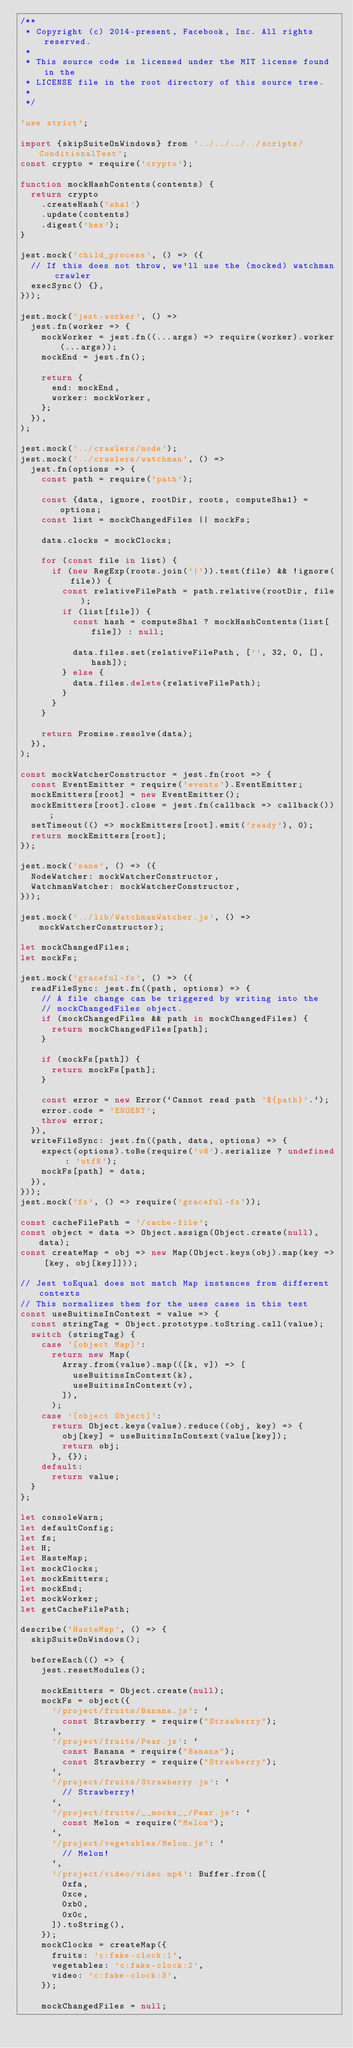Convert code to text. <code><loc_0><loc_0><loc_500><loc_500><_JavaScript_>/**
 * Copyright (c) 2014-present, Facebook, Inc. All rights reserved.
 *
 * This source code is licensed under the MIT license found in the
 * LICENSE file in the root directory of this source tree.
 *
 */

'use strict';

import {skipSuiteOnWindows} from '../../../../scripts/ConditionalTest';
const crypto = require('crypto');

function mockHashContents(contents) {
  return crypto
    .createHash('sha1')
    .update(contents)
    .digest('hex');
}

jest.mock('child_process', () => ({
  // If this does not throw, we'll use the (mocked) watchman crawler
  execSync() {},
}));

jest.mock('jest-worker', () =>
  jest.fn(worker => {
    mockWorker = jest.fn((...args) => require(worker).worker(...args));
    mockEnd = jest.fn();

    return {
      end: mockEnd,
      worker: mockWorker,
    };
  }),
);

jest.mock('../crawlers/node');
jest.mock('../crawlers/watchman', () =>
  jest.fn(options => {
    const path = require('path');

    const {data, ignore, rootDir, roots, computeSha1} = options;
    const list = mockChangedFiles || mockFs;

    data.clocks = mockClocks;

    for (const file in list) {
      if (new RegExp(roots.join('|')).test(file) && !ignore(file)) {
        const relativeFilePath = path.relative(rootDir, file);
        if (list[file]) {
          const hash = computeSha1 ? mockHashContents(list[file]) : null;

          data.files.set(relativeFilePath, ['', 32, 0, [], hash]);
        } else {
          data.files.delete(relativeFilePath);
        }
      }
    }

    return Promise.resolve(data);
  }),
);

const mockWatcherConstructor = jest.fn(root => {
  const EventEmitter = require('events').EventEmitter;
  mockEmitters[root] = new EventEmitter();
  mockEmitters[root].close = jest.fn(callback => callback());
  setTimeout(() => mockEmitters[root].emit('ready'), 0);
  return mockEmitters[root];
});

jest.mock('sane', () => ({
  NodeWatcher: mockWatcherConstructor,
  WatchmanWatcher: mockWatcherConstructor,
}));

jest.mock('../lib/WatchmanWatcher.js', () => mockWatcherConstructor);

let mockChangedFiles;
let mockFs;

jest.mock('graceful-fs', () => ({
  readFileSync: jest.fn((path, options) => {
    // A file change can be triggered by writing into the
    // mockChangedFiles object.
    if (mockChangedFiles && path in mockChangedFiles) {
      return mockChangedFiles[path];
    }

    if (mockFs[path]) {
      return mockFs[path];
    }

    const error = new Error(`Cannot read path '${path}'.`);
    error.code = 'ENOENT';
    throw error;
  }),
  writeFileSync: jest.fn((path, data, options) => {
    expect(options).toBe(require('v8').serialize ? undefined : 'utf8');
    mockFs[path] = data;
  }),
}));
jest.mock('fs', () => require('graceful-fs'));

const cacheFilePath = '/cache-file';
const object = data => Object.assign(Object.create(null), data);
const createMap = obj => new Map(Object.keys(obj).map(key => [key, obj[key]]));

// Jest toEqual does not match Map instances from different contexts
// This normalizes them for the uses cases in this test
const useBuitinsInContext = value => {
  const stringTag = Object.prototype.toString.call(value);
  switch (stringTag) {
    case '[object Map]':
      return new Map(
        Array.from(value).map(([k, v]) => [
          useBuitinsInContext(k),
          useBuitinsInContext(v),
        ]),
      );
    case '[object Object]':
      return Object.keys(value).reduce((obj, key) => {
        obj[key] = useBuitinsInContext(value[key]);
        return obj;
      }, {});
    default:
      return value;
  }
};

let consoleWarn;
let defaultConfig;
let fs;
let H;
let HasteMap;
let mockClocks;
let mockEmitters;
let mockEnd;
let mockWorker;
let getCacheFilePath;

describe('HasteMap', () => {
  skipSuiteOnWindows();

  beforeEach(() => {
    jest.resetModules();

    mockEmitters = Object.create(null);
    mockFs = object({
      '/project/fruits/Banana.js': `
        const Strawberry = require("Strawberry");
      `,
      '/project/fruits/Pear.js': `
        const Banana = require("Banana");
        const Strawberry = require("Strawberry");
      `,
      '/project/fruits/Strawberry.js': `
        // Strawberry!
      `,
      '/project/fruits/__mocks__/Pear.js': `
        const Melon = require("Melon");
      `,
      '/project/vegetables/Melon.js': `
        // Melon!
      `,
      '/project/video/video.mp4': Buffer.from([
        0xfa,
        0xce,
        0xb0,
        0x0c,
      ]).toString(),
    });
    mockClocks = createMap({
      fruits: 'c:fake-clock:1',
      vegetables: 'c:fake-clock:2',
      video: 'c:fake-clock:3',
    });

    mockChangedFiles = null;
</code> 